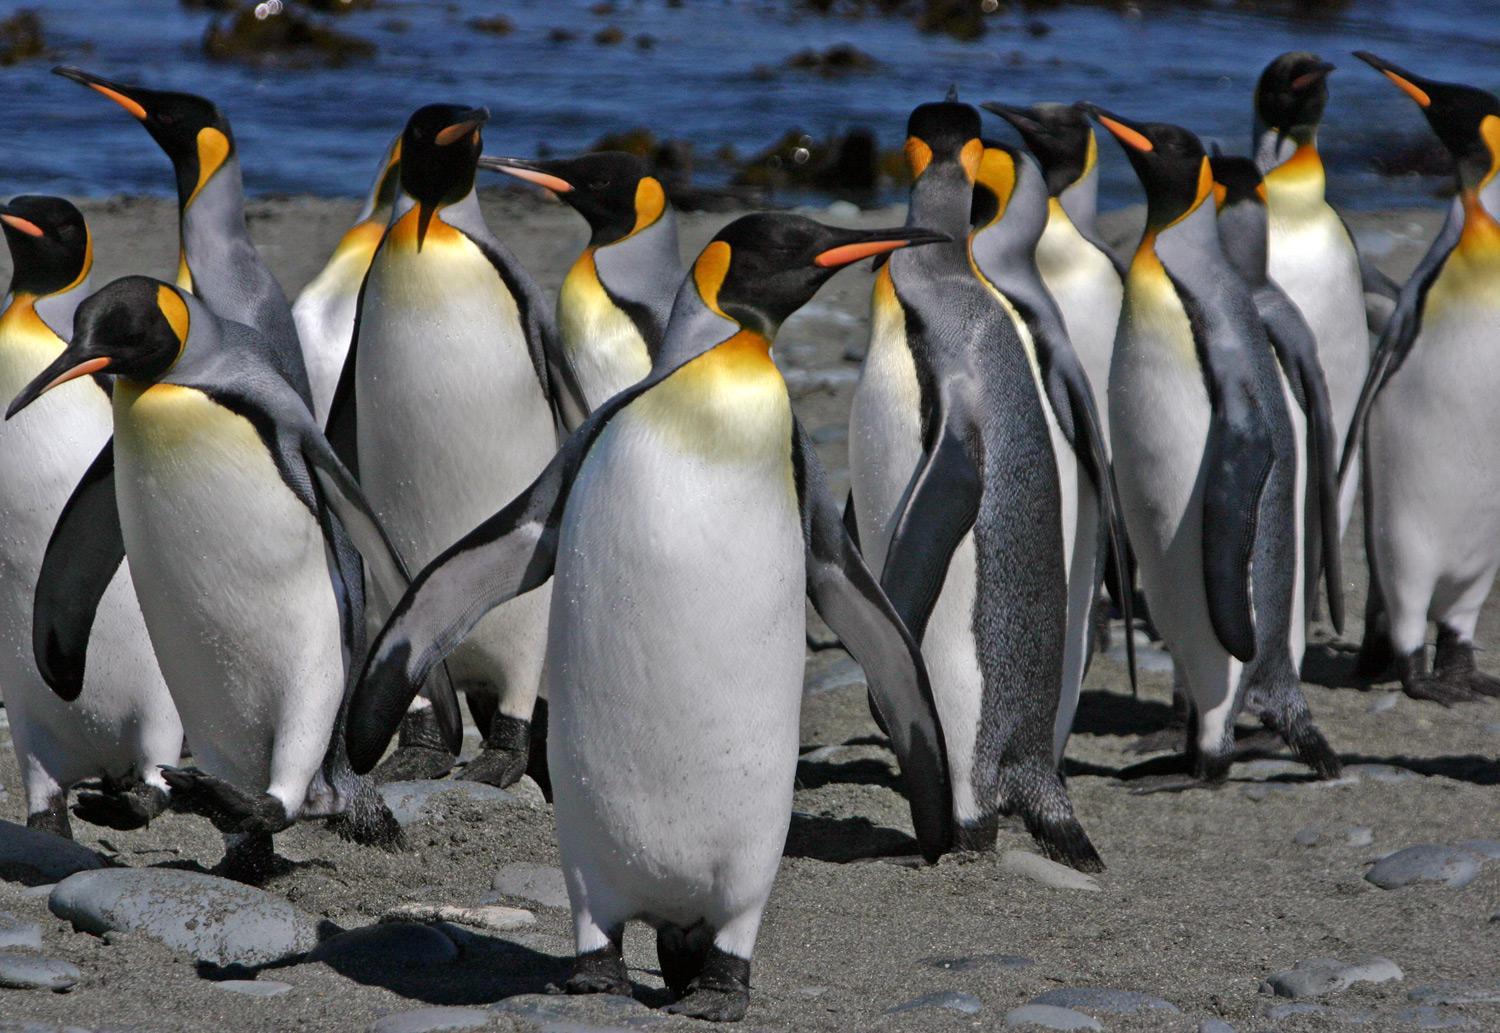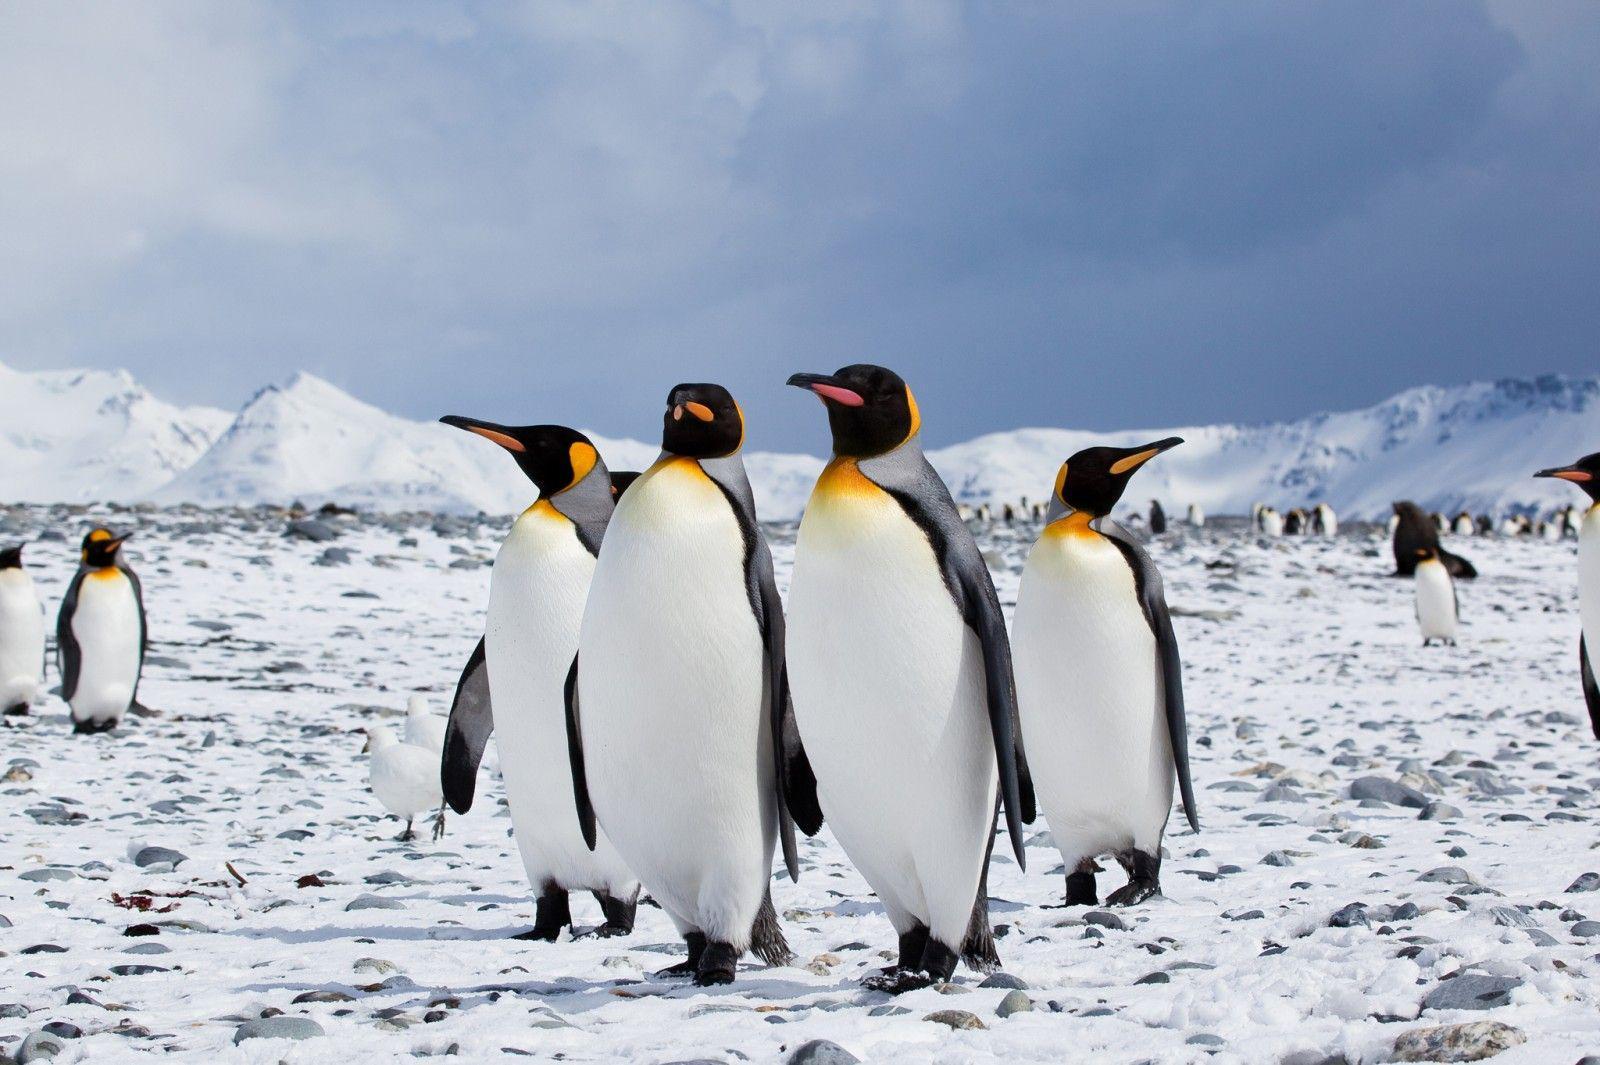The first image is the image on the left, the second image is the image on the right. For the images shown, is this caption "The right image contains no more than one penguin." true? Answer yes or no. No. 